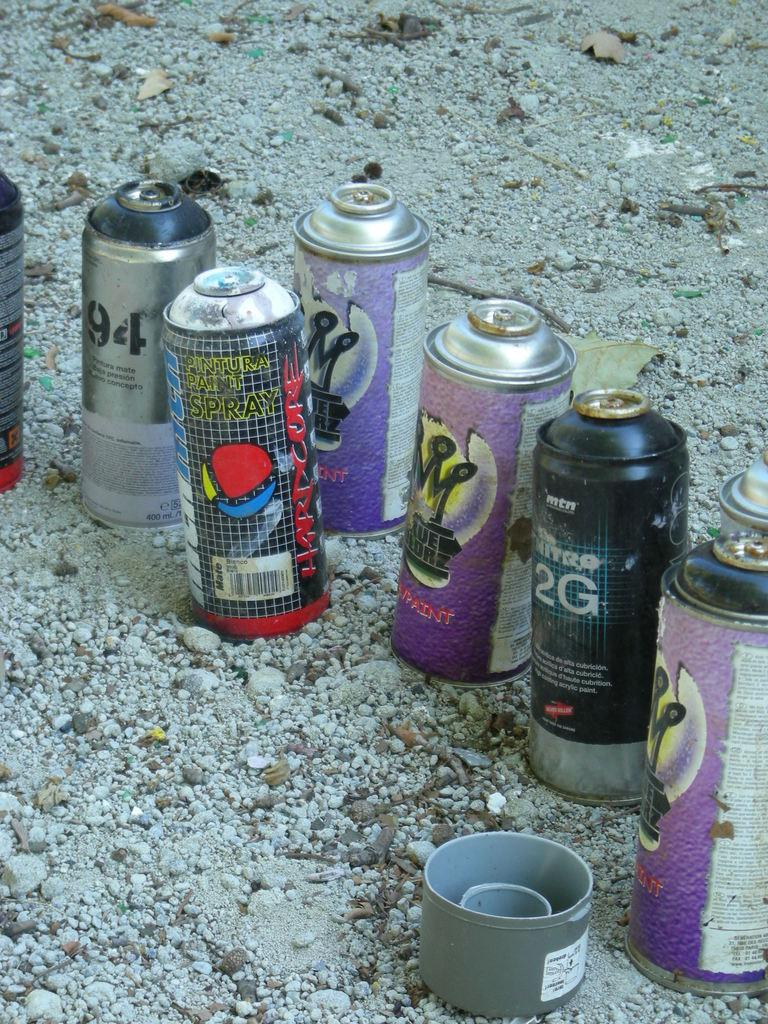Provide a one-sentence caption for the provided image. Several bottles of open spray paint sit in the gravel, including paint called Hardcore. 